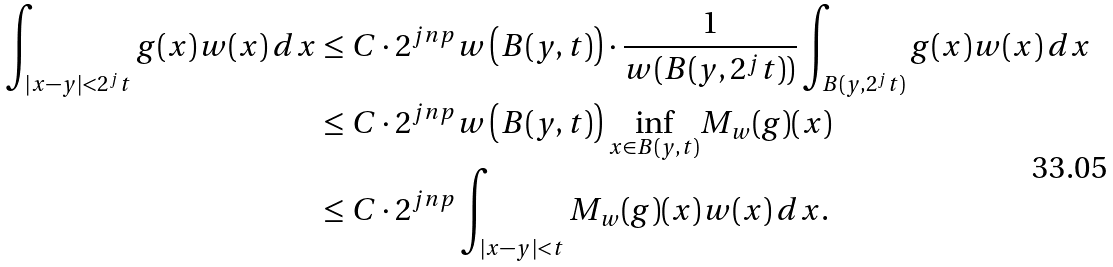<formula> <loc_0><loc_0><loc_500><loc_500>\int _ { | x - y | < 2 ^ { j } t } g ( x ) w ( x ) \, d x & \leq C \cdot 2 ^ { j n p } w \left ( B ( y , t ) \right ) \cdot \frac { 1 } { w ( B ( y , 2 ^ { j } t ) ) } \int _ { B ( y , 2 ^ { j } t ) } g ( x ) w ( x ) \, d x \\ & \leq C \cdot 2 ^ { j n p } w \left ( B ( y , t ) \right ) \underset { x \in B ( y , t ) } { \inf } M _ { w } ( g ) ( x ) \\ & \leq C \cdot 2 ^ { j n p } \int _ { | x - y | < t } M _ { w } ( g ) ( x ) w ( x ) \, d x .</formula> 